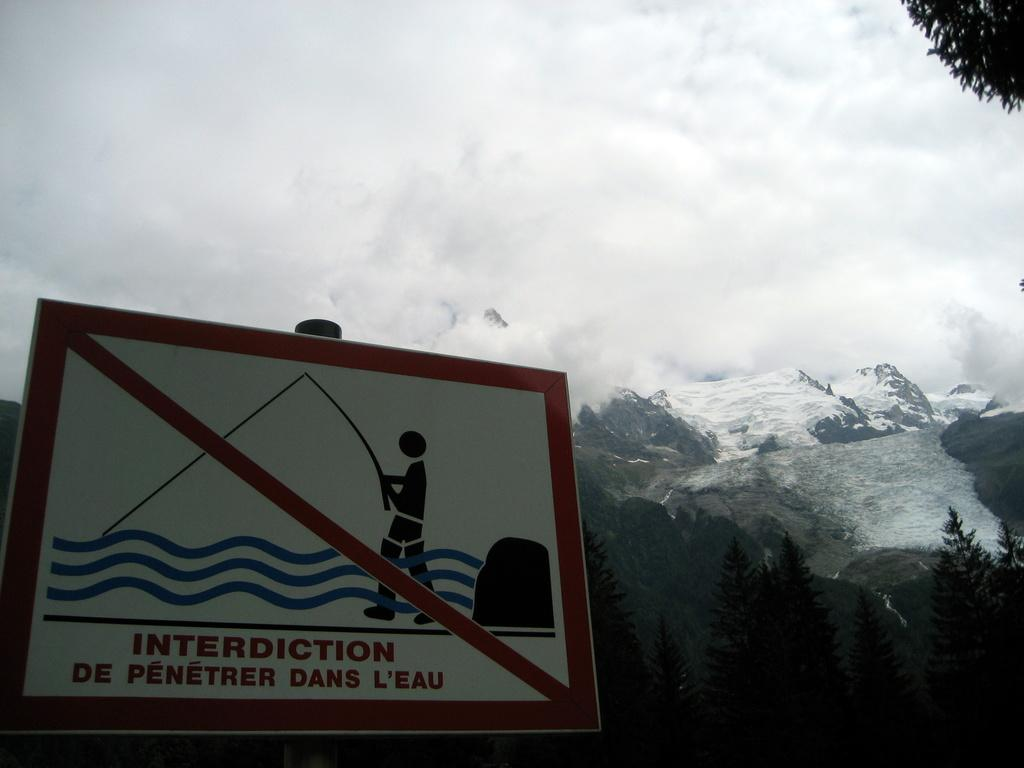<image>
Describe the image concisely. a sign with a fisherman that says interdiction on it 